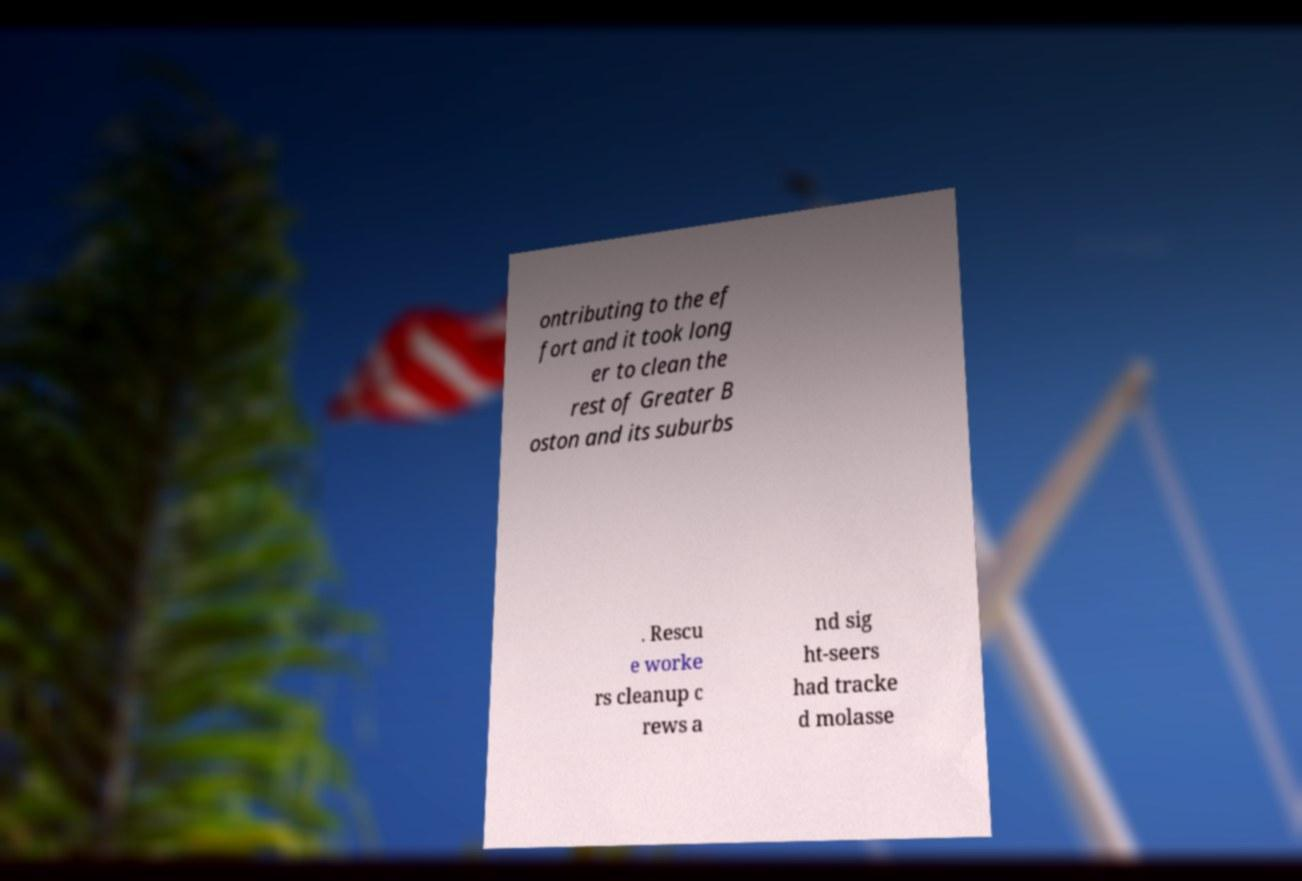Can you read and provide the text displayed in the image?This photo seems to have some interesting text. Can you extract and type it out for me? ontributing to the ef fort and it took long er to clean the rest of Greater B oston and its suburbs . Rescu e worke rs cleanup c rews a nd sig ht-seers had tracke d molasse 